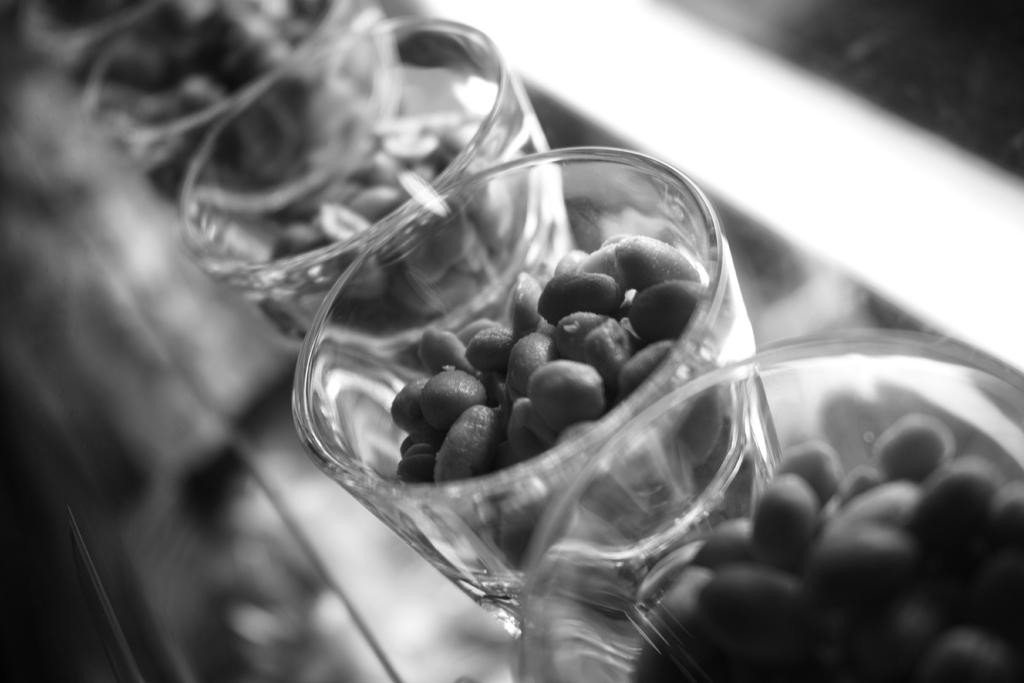What is present in the image? There are seeds in the image. How are the seeds arranged or contained? The seeds are placed in several glasses. What type of camp can be seen in the image? There is no camp present in the image; it only contains seeds in glasses. What is the skin condition of the seeds in the image? The seeds do not have a skin condition, as they are inanimate objects. 